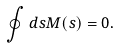<formula> <loc_0><loc_0><loc_500><loc_500>\oint d s { M } ( s ) = 0 .</formula> 